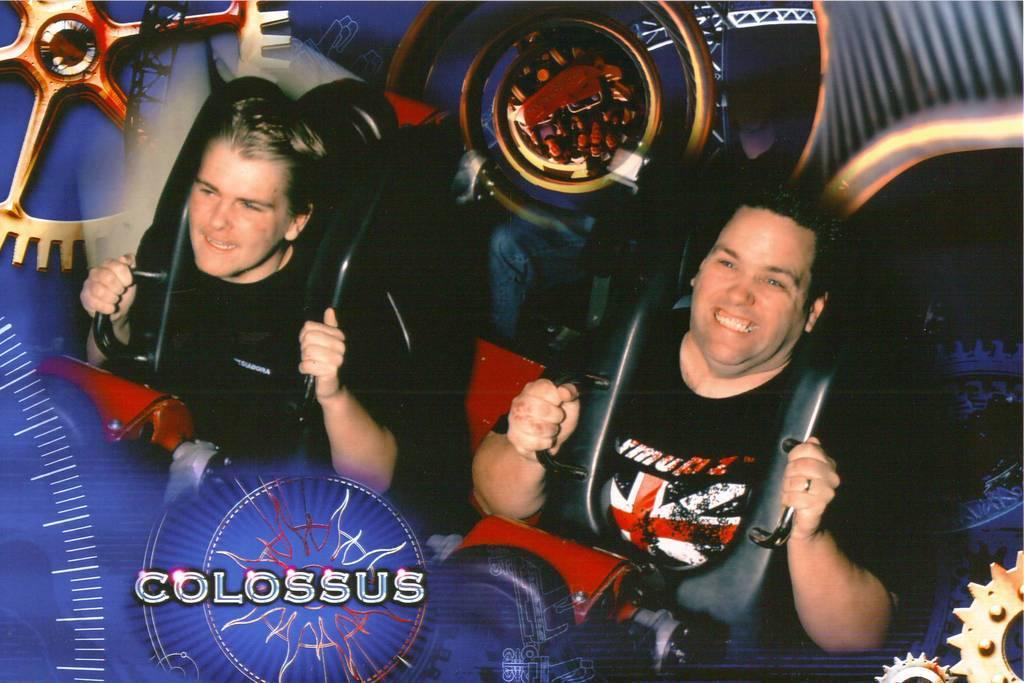Could you give a brief overview of what you see in this image? This looks like an edited image. I can see two men sitting and smiling. They wore a seatbelt. These look like the letters in the image. 